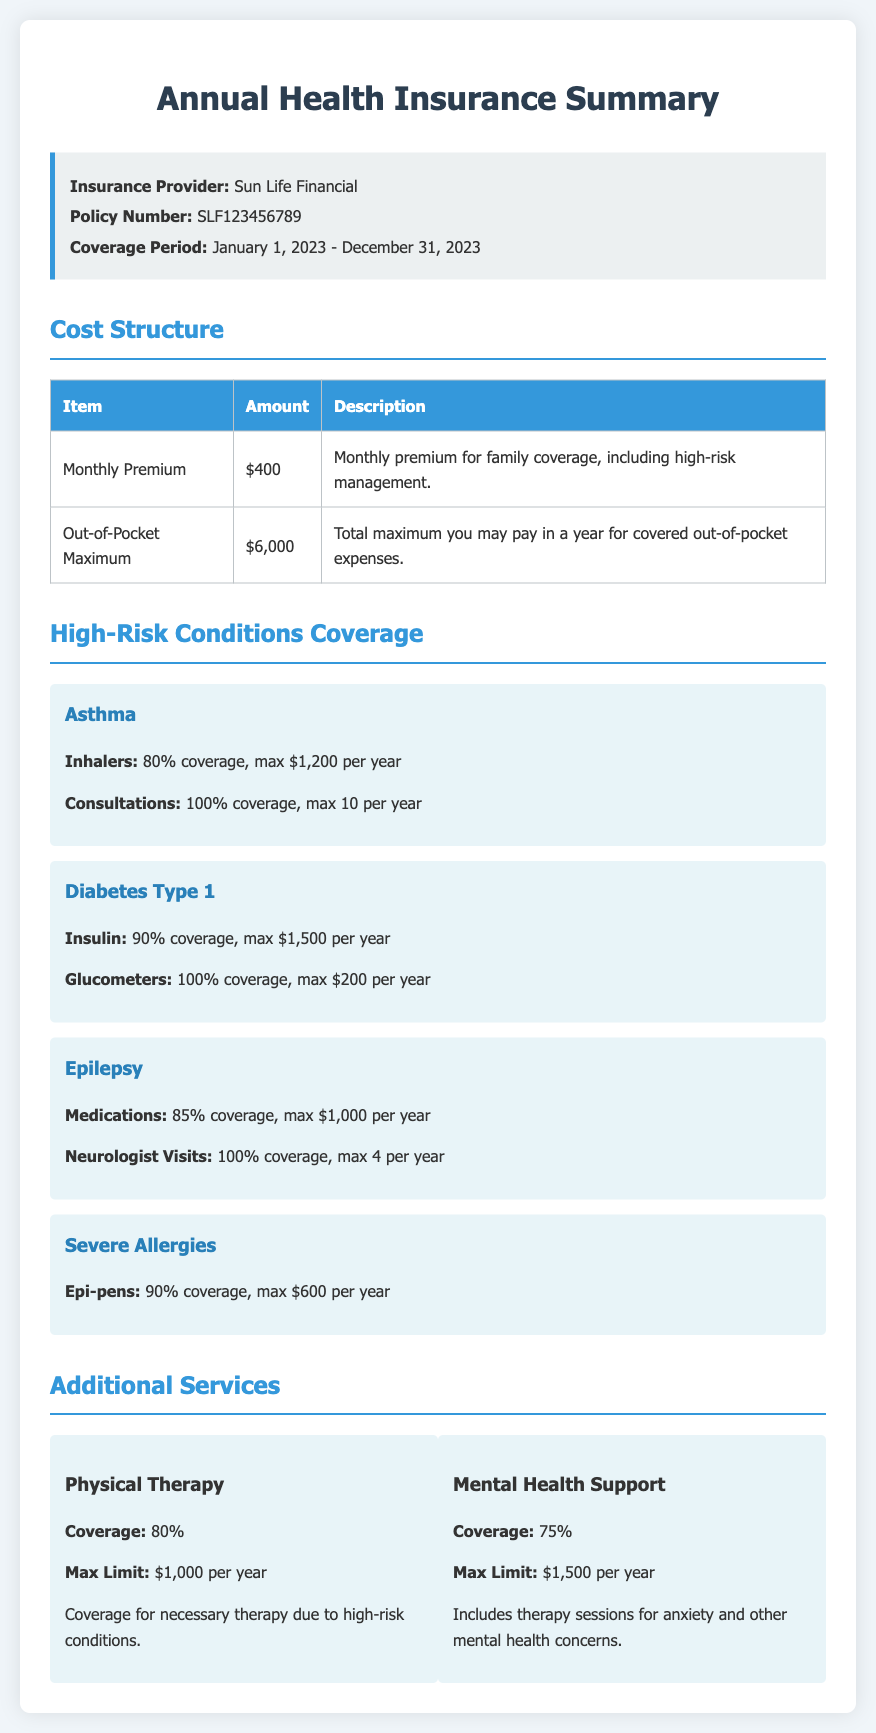what is the insurance provider? The insurance provider listed in the document is clearly stated at the beginning.
Answer: Sun Life Financial what is the monthly premium for family coverage? The document specifies the amount for the monthly premium under the cost structure section.
Answer: $400 what is the out-of-pocket maximum for the year? This value is provided in the cost structure section of the document.
Answer: $6,000 how much is covered for asthma inhalers? The coverage amount for asthma inhalers is detailed under the High-Risk Conditions Coverage section.
Answer: 80% coverage, max $1,200 per year how many consultations for asthma are fully covered per year? The fully covered consultations for asthma can be found in the same section as other asthma details.
Answer: 10 per year what is the maximum coverage for Type 1 diabetes insulin? This information is included in the description of coverage for diabetes Type 1.
Answer: $1,500 per year what percentage is covered for physical therapy? The coverage percentage for physical therapy is indicated in the Additional Services section.
Answer: 80% which condition has a maximum limit of $600 for Epi-pens? The condition associated with this limit is specified in the High-Risk Conditions Coverage section.
Answer: Severe Allergies how much is the coverage for mental health support? The percentage of coverage for mental health support is clearly stated in the document.
Answer: 75% 